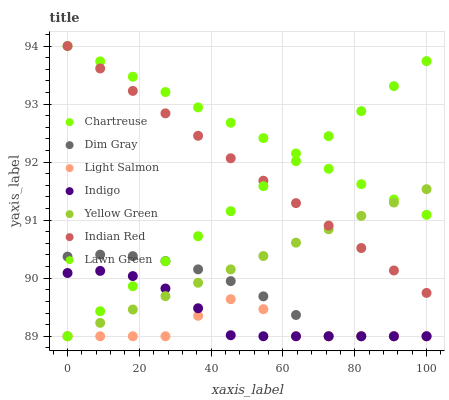Does Light Salmon have the minimum area under the curve?
Answer yes or no. Yes. Does Chartreuse have the maximum area under the curve?
Answer yes or no. Yes. Does Dim Gray have the minimum area under the curve?
Answer yes or no. No. Does Dim Gray have the maximum area under the curve?
Answer yes or no. No. Is Chartreuse the smoothest?
Answer yes or no. Yes. Is Light Salmon the roughest?
Answer yes or no. Yes. Is Dim Gray the smoothest?
Answer yes or no. No. Is Dim Gray the roughest?
Answer yes or no. No. Does Lawn Green have the lowest value?
Answer yes or no. Yes. Does Chartreuse have the lowest value?
Answer yes or no. No. Does Indian Red have the highest value?
Answer yes or no. Yes. Does Dim Gray have the highest value?
Answer yes or no. No. Is Light Salmon less than Chartreuse?
Answer yes or no. Yes. Is Indian Red greater than Light Salmon?
Answer yes or no. Yes. Does Yellow Green intersect Indian Red?
Answer yes or no. Yes. Is Yellow Green less than Indian Red?
Answer yes or no. No. Is Yellow Green greater than Indian Red?
Answer yes or no. No. Does Light Salmon intersect Chartreuse?
Answer yes or no. No. 